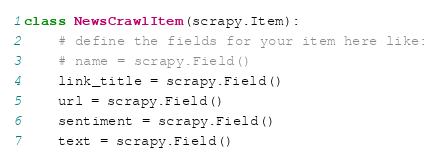Convert code to text. <code><loc_0><loc_0><loc_500><loc_500><_Python_>
class NewsCrawlItem(scrapy.Item):
    # define the fields for your item here like:
    # name = scrapy.Field()
    link_title = scrapy.Field()
    url = scrapy.Field()
    sentiment = scrapy.Field()
    text = scrapy.Field()
</code> 